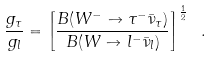<formula> <loc_0><loc_0><loc_500><loc_500>\frac { g _ { \tau } } { g _ { l } } = \left [ \frac { B ( W ^ { - } \to \tau ^ { - } \bar { \nu } _ { \tau } ) } { B ( W \to l ^ { - } \bar { \nu } _ { l } ) } \right ] ^ { \frac { 1 } { 2 } } \ .</formula> 